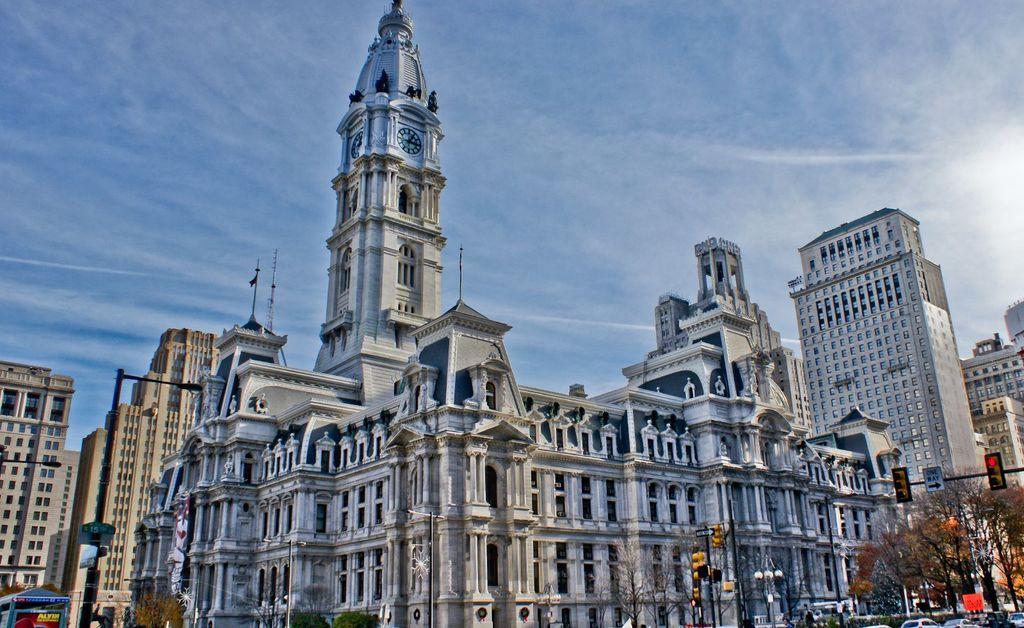Please provide a concise description of this image. In this picture I can see some buildings, trees, vehicles. 